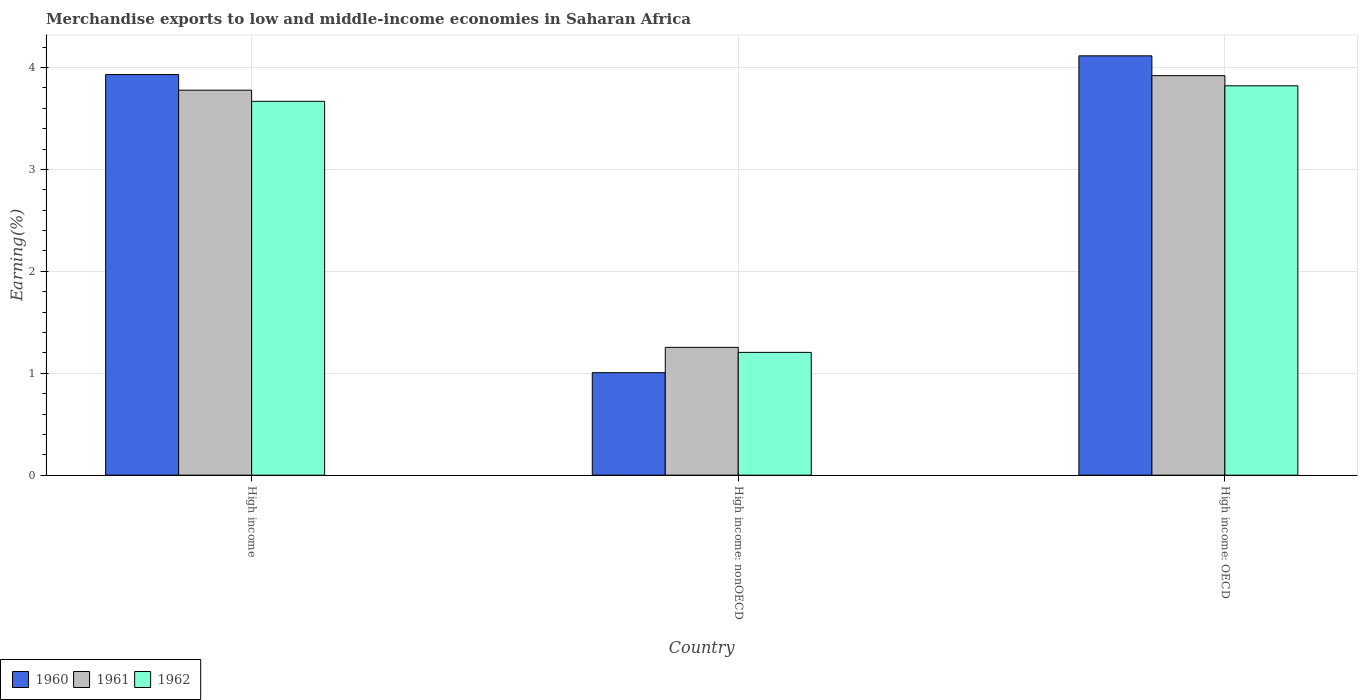How many different coloured bars are there?
Ensure brevity in your answer.  3. How many groups of bars are there?
Offer a very short reply. 3. What is the label of the 3rd group of bars from the left?
Make the answer very short. High income: OECD. What is the percentage of amount earned from merchandise exports in 1962 in High income?
Your answer should be very brief. 3.67. Across all countries, what is the maximum percentage of amount earned from merchandise exports in 1961?
Offer a terse response. 3.92. Across all countries, what is the minimum percentage of amount earned from merchandise exports in 1962?
Provide a succinct answer. 1.2. In which country was the percentage of amount earned from merchandise exports in 1962 maximum?
Your answer should be compact. High income: OECD. In which country was the percentage of amount earned from merchandise exports in 1961 minimum?
Your response must be concise. High income: nonOECD. What is the total percentage of amount earned from merchandise exports in 1960 in the graph?
Your answer should be compact. 9.05. What is the difference between the percentage of amount earned from merchandise exports in 1960 in High income and that in High income: OECD?
Your answer should be very brief. -0.18. What is the difference between the percentage of amount earned from merchandise exports in 1961 in High income: OECD and the percentage of amount earned from merchandise exports in 1960 in High income: nonOECD?
Keep it short and to the point. 2.91. What is the average percentage of amount earned from merchandise exports in 1960 per country?
Keep it short and to the point. 3.02. What is the difference between the percentage of amount earned from merchandise exports of/in 1961 and percentage of amount earned from merchandise exports of/in 1962 in High income: nonOECD?
Your response must be concise. 0.05. What is the ratio of the percentage of amount earned from merchandise exports in 1962 in High income to that in High income: OECD?
Offer a terse response. 0.96. What is the difference between the highest and the second highest percentage of amount earned from merchandise exports in 1962?
Make the answer very short. 2.46. What is the difference between the highest and the lowest percentage of amount earned from merchandise exports in 1962?
Ensure brevity in your answer.  2.62. What does the 1st bar from the left in High income: nonOECD represents?
Make the answer very short. 1960. What does the 1st bar from the right in High income: nonOECD represents?
Make the answer very short. 1962. How many countries are there in the graph?
Ensure brevity in your answer.  3. What is the title of the graph?
Offer a very short reply. Merchandise exports to low and middle-income economies in Saharan Africa. Does "1979" appear as one of the legend labels in the graph?
Provide a short and direct response. No. What is the label or title of the Y-axis?
Your response must be concise. Earning(%). What is the Earning(%) in 1960 in High income?
Your answer should be very brief. 3.93. What is the Earning(%) in 1961 in High income?
Provide a short and direct response. 3.78. What is the Earning(%) in 1962 in High income?
Offer a very short reply. 3.67. What is the Earning(%) in 1960 in High income: nonOECD?
Your answer should be very brief. 1.01. What is the Earning(%) in 1961 in High income: nonOECD?
Provide a succinct answer. 1.25. What is the Earning(%) in 1962 in High income: nonOECD?
Ensure brevity in your answer.  1.2. What is the Earning(%) in 1960 in High income: OECD?
Make the answer very short. 4.11. What is the Earning(%) of 1961 in High income: OECD?
Offer a terse response. 3.92. What is the Earning(%) of 1962 in High income: OECD?
Offer a very short reply. 3.82. Across all countries, what is the maximum Earning(%) of 1960?
Offer a very short reply. 4.11. Across all countries, what is the maximum Earning(%) of 1961?
Make the answer very short. 3.92. Across all countries, what is the maximum Earning(%) in 1962?
Offer a very short reply. 3.82. Across all countries, what is the minimum Earning(%) of 1960?
Provide a short and direct response. 1.01. Across all countries, what is the minimum Earning(%) in 1961?
Offer a very short reply. 1.25. Across all countries, what is the minimum Earning(%) of 1962?
Provide a succinct answer. 1.2. What is the total Earning(%) of 1960 in the graph?
Ensure brevity in your answer.  9.05. What is the total Earning(%) of 1961 in the graph?
Give a very brief answer. 8.95. What is the total Earning(%) of 1962 in the graph?
Make the answer very short. 8.69. What is the difference between the Earning(%) of 1960 in High income and that in High income: nonOECD?
Offer a very short reply. 2.93. What is the difference between the Earning(%) of 1961 in High income and that in High income: nonOECD?
Make the answer very short. 2.52. What is the difference between the Earning(%) of 1962 in High income and that in High income: nonOECD?
Ensure brevity in your answer.  2.46. What is the difference between the Earning(%) in 1960 in High income and that in High income: OECD?
Provide a succinct answer. -0.18. What is the difference between the Earning(%) in 1961 in High income and that in High income: OECD?
Ensure brevity in your answer.  -0.14. What is the difference between the Earning(%) of 1962 in High income and that in High income: OECD?
Provide a short and direct response. -0.15. What is the difference between the Earning(%) in 1960 in High income: nonOECD and that in High income: OECD?
Provide a short and direct response. -3.11. What is the difference between the Earning(%) of 1961 in High income: nonOECD and that in High income: OECD?
Give a very brief answer. -2.67. What is the difference between the Earning(%) in 1962 in High income: nonOECD and that in High income: OECD?
Make the answer very short. -2.62. What is the difference between the Earning(%) in 1960 in High income and the Earning(%) in 1961 in High income: nonOECD?
Offer a very short reply. 2.68. What is the difference between the Earning(%) of 1960 in High income and the Earning(%) of 1962 in High income: nonOECD?
Make the answer very short. 2.73. What is the difference between the Earning(%) of 1961 in High income and the Earning(%) of 1962 in High income: nonOECD?
Keep it short and to the point. 2.57. What is the difference between the Earning(%) in 1960 in High income and the Earning(%) in 1961 in High income: OECD?
Offer a very short reply. 0.01. What is the difference between the Earning(%) of 1960 in High income and the Earning(%) of 1962 in High income: OECD?
Your answer should be compact. 0.11. What is the difference between the Earning(%) in 1961 in High income and the Earning(%) in 1962 in High income: OECD?
Make the answer very short. -0.04. What is the difference between the Earning(%) of 1960 in High income: nonOECD and the Earning(%) of 1961 in High income: OECD?
Your response must be concise. -2.91. What is the difference between the Earning(%) of 1960 in High income: nonOECD and the Earning(%) of 1962 in High income: OECD?
Offer a terse response. -2.81. What is the difference between the Earning(%) of 1961 in High income: nonOECD and the Earning(%) of 1962 in High income: OECD?
Your response must be concise. -2.57. What is the average Earning(%) in 1960 per country?
Give a very brief answer. 3.02. What is the average Earning(%) of 1961 per country?
Your answer should be very brief. 2.98. What is the average Earning(%) of 1962 per country?
Provide a short and direct response. 2.9. What is the difference between the Earning(%) in 1960 and Earning(%) in 1961 in High income?
Keep it short and to the point. 0.15. What is the difference between the Earning(%) of 1960 and Earning(%) of 1962 in High income?
Give a very brief answer. 0.26. What is the difference between the Earning(%) of 1961 and Earning(%) of 1962 in High income?
Offer a very short reply. 0.11. What is the difference between the Earning(%) in 1960 and Earning(%) in 1961 in High income: nonOECD?
Keep it short and to the point. -0.25. What is the difference between the Earning(%) of 1960 and Earning(%) of 1962 in High income: nonOECD?
Offer a very short reply. -0.2. What is the difference between the Earning(%) in 1961 and Earning(%) in 1962 in High income: nonOECD?
Ensure brevity in your answer.  0.05. What is the difference between the Earning(%) of 1960 and Earning(%) of 1961 in High income: OECD?
Your answer should be compact. 0.19. What is the difference between the Earning(%) of 1960 and Earning(%) of 1962 in High income: OECD?
Provide a succinct answer. 0.29. What is the difference between the Earning(%) of 1961 and Earning(%) of 1962 in High income: OECD?
Your response must be concise. 0.1. What is the ratio of the Earning(%) in 1960 in High income to that in High income: nonOECD?
Keep it short and to the point. 3.91. What is the ratio of the Earning(%) in 1961 in High income to that in High income: nonOECD?
Offer a very short reply. 3.01. What is the ratio of the Earning(%) of 1962 in High income to that in High income: nonOECD?
Keep it short and to the point. 3.04. What is the ratio of the Earning(%) in 1960 in High income to that in High income: OECD?
Provide a succinct answer. 0.96. What is the ratio of the Earning(%) of 1961 in High income to that in High income: OECD?
Make the answer very short. 0.96. What is the ratio of the Earning(%) in 1962 in High income to that in High income: OECD?
Your answer should be very brief. 0.96. What is the ratio of the Earning(%) of 1960 in High income: nonOECD to that in High income: OECD?
Provide a succinct answer. 0.24. What is the ratio of the Earning(%) in 1961 in High income: nonOECD to that in High income: OECD?
Provide a succinct answer. 0.32. What is the ratio of the Earning(%) of 1962 in High income: nonOECD to that in High income: OECD?
Make the answer very short. 0.32. What is the difference between the highest and the second highest Earning(%) of 1960?
Offer a terse response. 0.18. What is the difference between the highest and the second highest Earning(%) in 1961?
Offer a very short reply. 0.14. What is the difference between the highest and the second highest Earning(%) of 1962?
Keep it short and to the point. 0.15. What is the difference between the highest and the lowest Earning(%) in 1960?
Provide a succinct answer. 3.11. What is the difference between the highest and the lowest Earning(%) of 1961?
Your answer should be compact. 2.67. What is the difference between the highest and the lowest Earning(%) of 1962?
Ensure brevity in your answer.  2.62. 